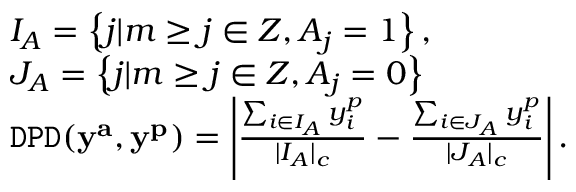Convert formula to latex. <formula><loc_0><loc_0><loc_500><loc_500>\begin{array} { r l } & { I _ { A } = \left \{ j | m \geq j \in Z , A _ { j } = 1 \right \} , } \\ & { J _ { A } = \left \{ j | m \geq j \in Z , A _ { j } = 0 \right \} } \\ & { { \tt D P D } ( y ^ { a } , y ^ { p } ) = \left | \frac { \sum _ { i \in I _ { A } } y _ { i } ^ { p } } { | I _ { A } | _ { c } } - \frac { \sum _ { i \in J _ { A } } y _ { i } ^ { p } } { | J _ { A } | _ { c } } \right | . } \end{array}</formula> 